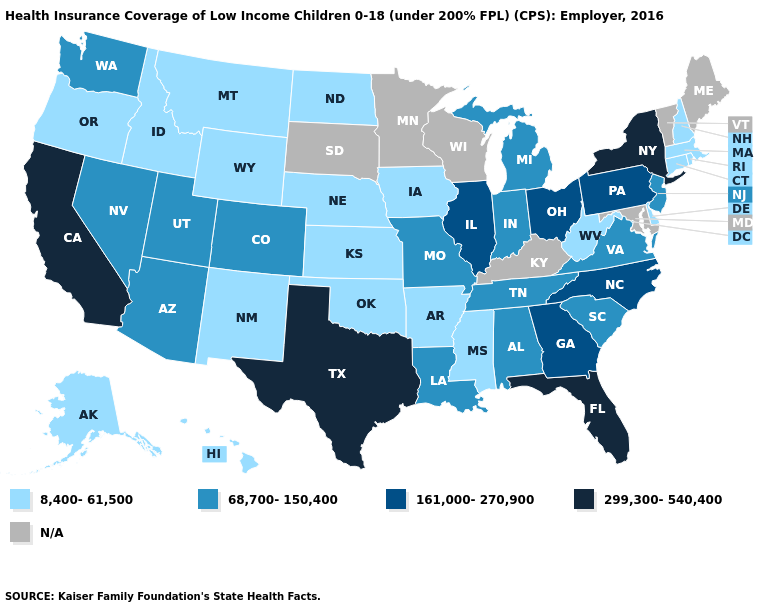Among the states that border New Mexico , which have the highest value?
Answer briefly. Texas. What is the value of Texas?
Quick response, please. 299,300-540,400. What is the value of Tennessee?
Concise answer only. 68,700-150,400. Among the states that border Alabama , does Florida have the lowest value?
Be succinct. No. Among the states that border Pennsylvania , does Delaware have the lowest value?
Give a very brief answer. Yes. Name the states that have a value in the range 161,000-270,900?
Give a very brief answer. Georgia, Illinois, North Carolina, Ohio, Pennsylvania. Does Washington have the lowest value in the West?
Quick response, please. No. Name the states that have a value in the range N/A?
Short answer required. Kentucky, Maine, Maryland, Minnesota, South Dakota, Vermont, Wisconsin. What is the value of Michigan?
Write a very short answer. 68,700-150,400. What is the value of Georgia?
Write a very short answer. 161,000-270,900. What is the lowest value in the West?
Write a very short answer. 8,400-61,500. Among the states that border Oklahoma , does Missouri have the highest value?
Write a very short answer. No. Name the states that have a value in the range 161,000-270,900?
Write a very short answer. Georgia, Illinois, North Carolina, Ohio, Pennsylvania. Name the states that have a value in the range 299,300-540,400?
Give a very brief answer. California, Florida, New York, Texas. 